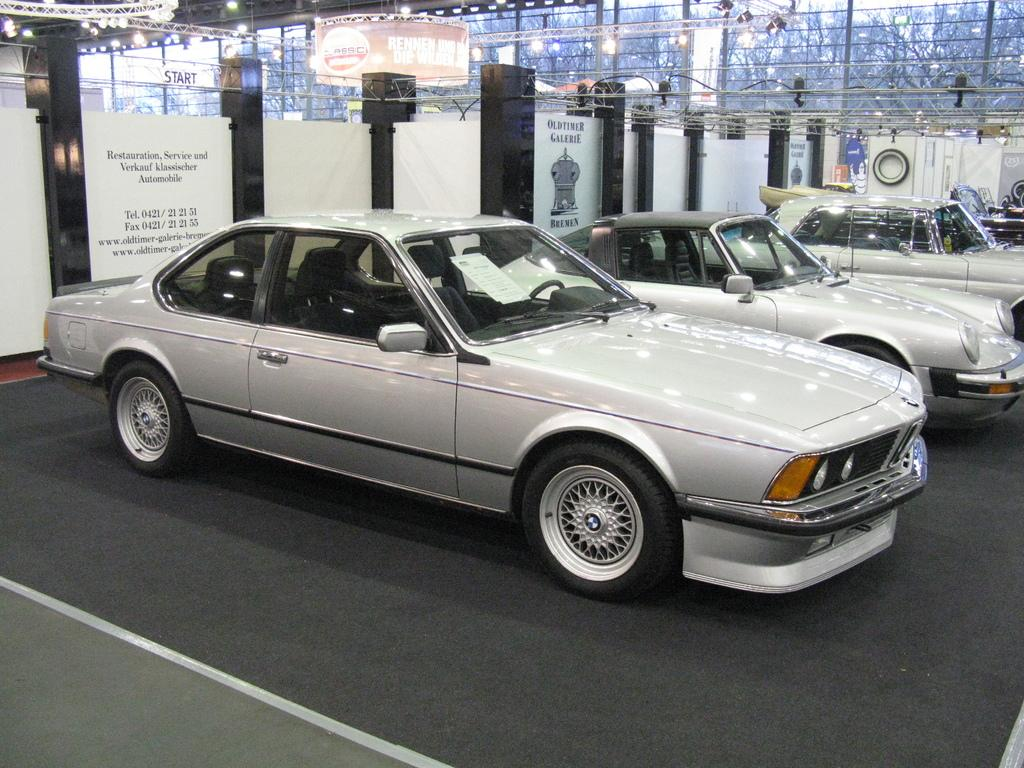What type of vehicles can be seen in the image? There are cars in the image. Can you describe any other features visible in the image? There are lights visible at the top of the image. Is there a rabbit hopping around the cars in the image? No, there is no rabbit present in the image. Can you tell me how the parent is interacting with the cars in the image? There is no parent or interaction with the cars mentioned in the image. 